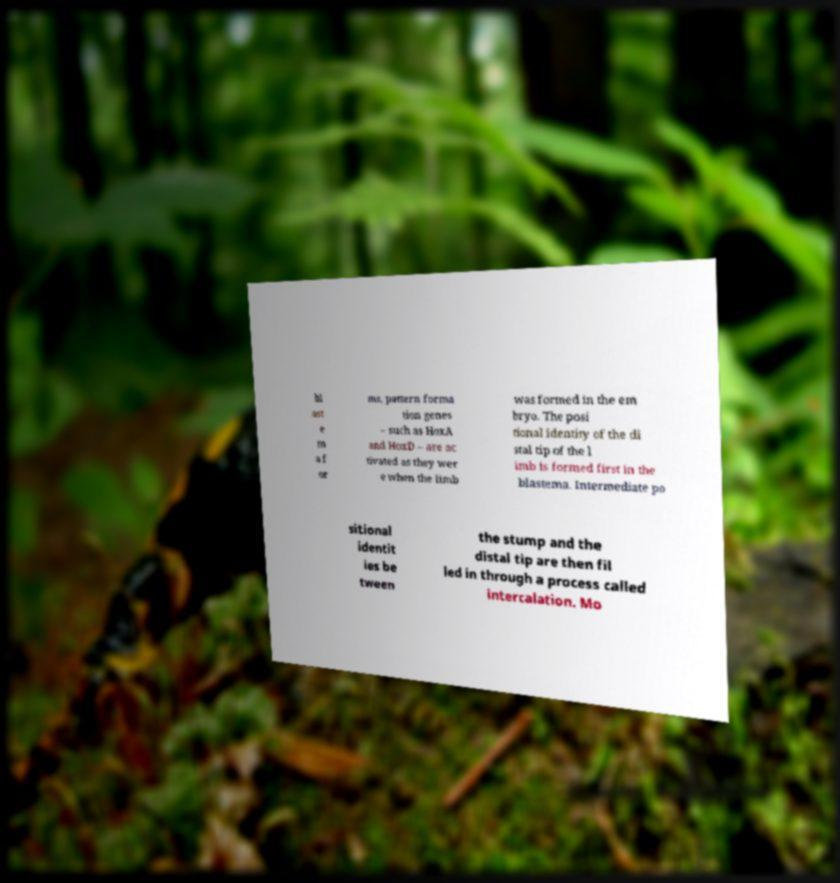I need the written content from this picture converted into text. Can you do that? bl ast e m a f or ms, pattern forma tion genes – such as HoxA and HoxD – are ac tivated as they wer e when the limb was formed in the em bryo. The posi tional identity of the di stal tip of the l imb is formed first in the blastema. Intermediate po sitional identit ies be tween the stump and the distal tip are then fil led in through a process called intercalation. Mo 